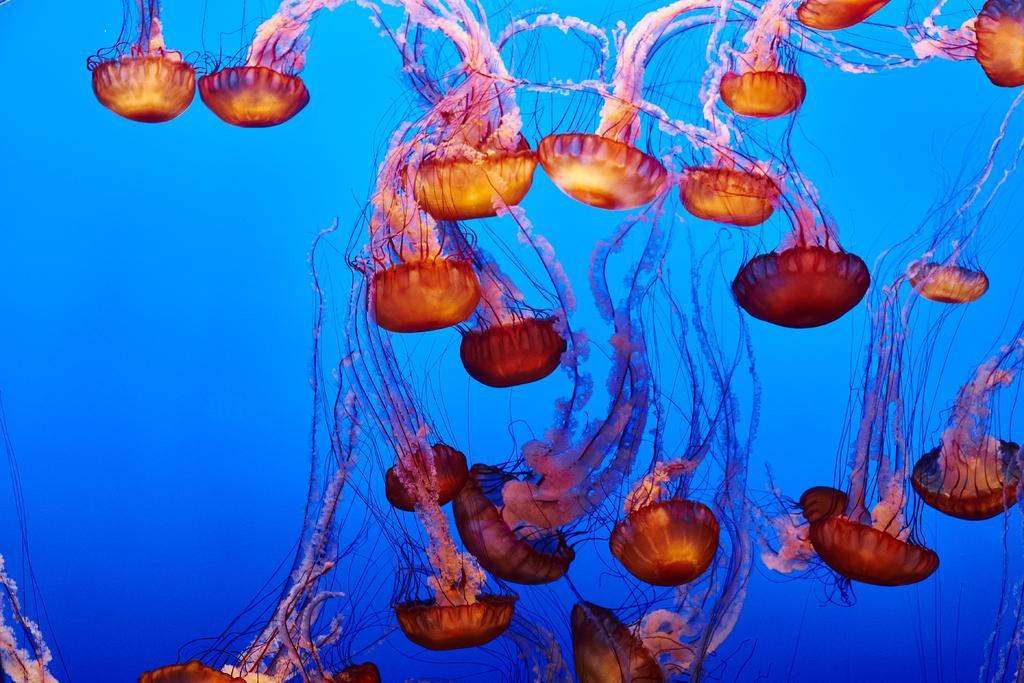In one or two sentences, can you explain what this image depicts? In this image, I can see the jelly fishes moving in the water. This water is blue in color. 